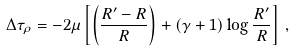<formula> <loc_0><loc_0><loc_500><loc_500>\Delta \tau _ { \rho } = - 2 \mu \left [ \left ( \frac { R ^ { \prime } - R } { R } \right ) + ( \gamma + 1 ) \log \frac { R ^ { \prime } } { R } \right ] \, ,</formula> 